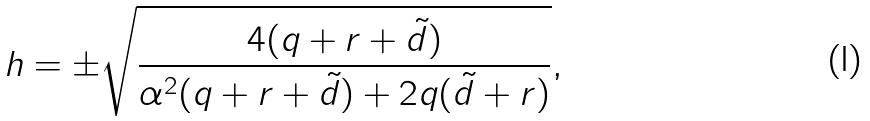<formula> <loc_0><loc_0><loc_500><loc_500>h = \pm \sqrt { \frac { 4 ( q + r + { \tilde { d } } ) } { \alpha ^ { 2 } ( q + r + { \tilde { d } } ) + 2 q ( { \tilde { d } } + r ) } } ,</formula> 